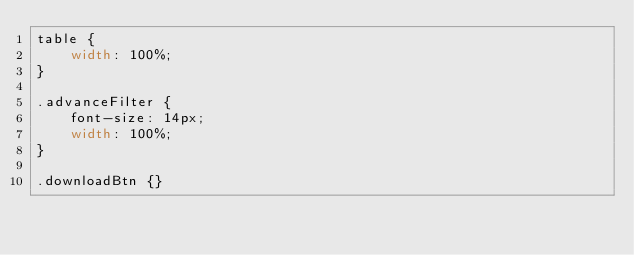<code> <loc_0><loc_0><loc_500><loc_500><_CSS_>table {
    width: 100%;
}

.advanceFilter {
    font-size: 14px;
    width: 100%;
}

.downloadBtn {}</code> 